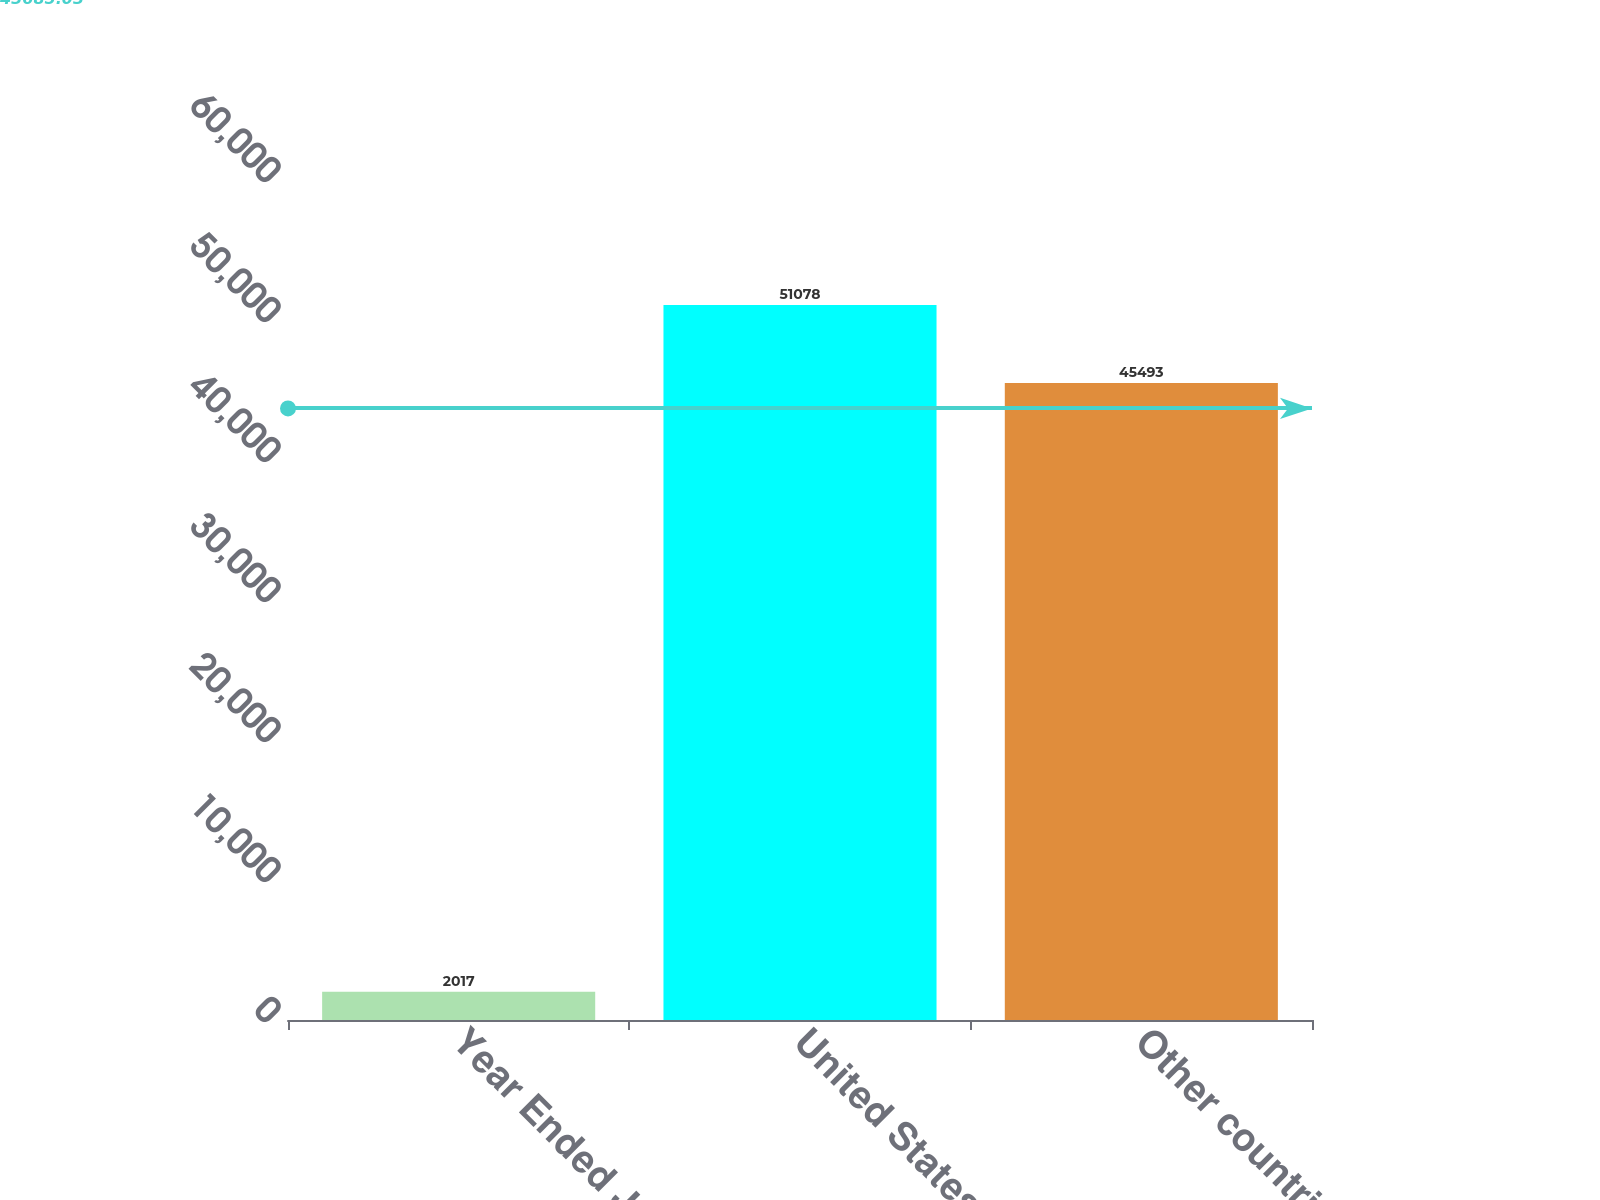Convert chart to OTSL. <chart><loc_0><loc_0><loc_500><loc_500><bar_chart><fcel>Year Ended June 30<fcel>United States (a)<fcel>Other countries<nl><fcel>2017<fcel>51078<fcel>45493<nl></chart> 